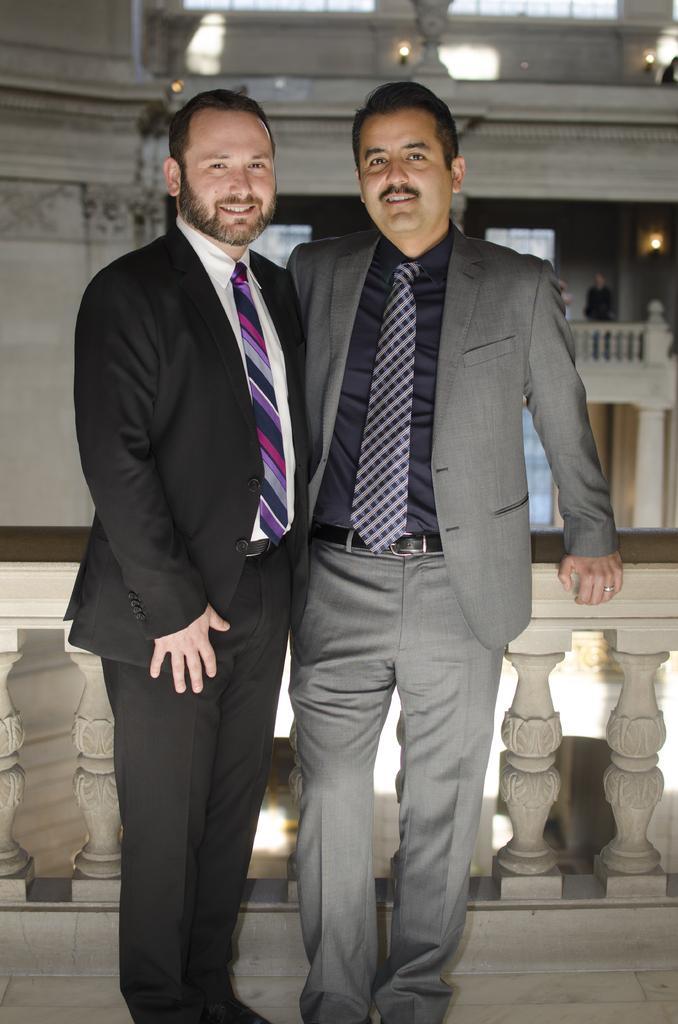Can you describe this image briefly? In this image we can see these two persons wearing blazers and ties are standing on the floor. In the background, we can see the inner view of the building. 